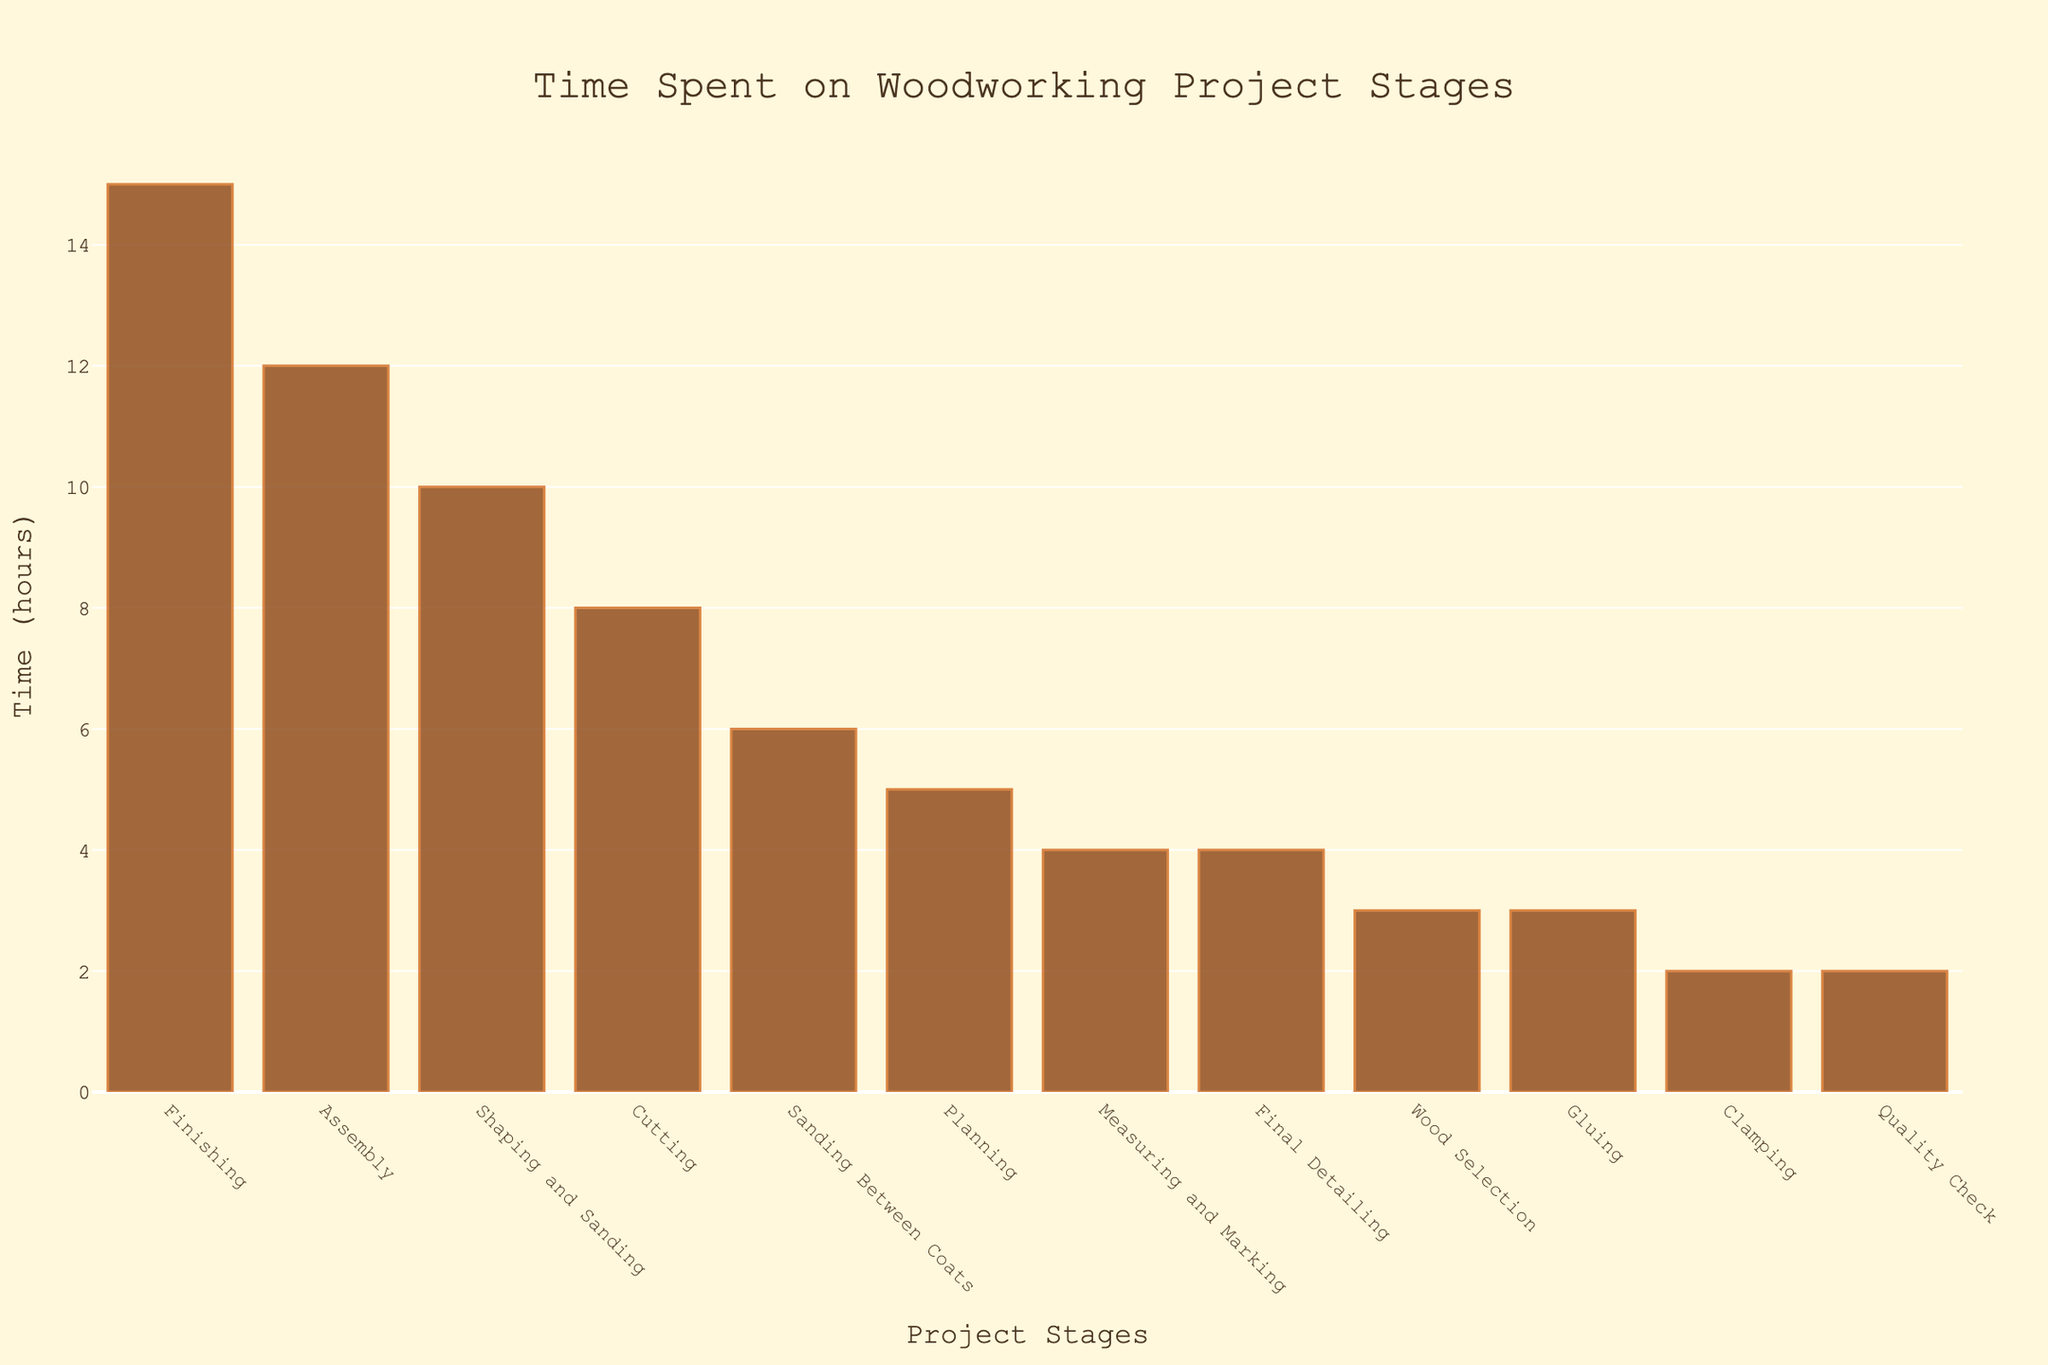Which stage takes the most time to complete? By looking at the bar chart, identify the stage with the tallest bar which represents the longest time spent.
Answer: Finishing Which stage takes the least time to complete? By looking at the bar chart, identify the stage with the shortest bar which represents the shortest time spent.
Answer: Clamping How much time is spent in the Assembly stage compared to the Planning stage? Look at the heights of the bars for the Assembly and Planning stages. The Assembly stage is 12 hours, and the Planning stage is 5 hours. Subtract the Planning time from the Assembly time. 12 - 5 = 7
Answer: 7 hours more What is the total time spent on Planning, Cutting, and Assembly stages combined? Add the times for Planning (5 hours), Cutting (8 hours), and Assembly (12 hours). 5 + 8 + 12 = 25
Answer: 25 hours Is the time spent on Shaping and Sanding greater than the time spent on Measuring and Marking? Compare the bar heights of Shaping and Sanding (10 hours) and Measuring and Marking (4 hours). Since 10 > 4, the answer is yes.
Answer: Yes Which stages take exactly 2 hours to complete? Search the bar chart for stages where the bar height is equal to 2 hours. These stages are Clamping and Quality Check.
Answer: Clamping, Quality Check What is the combined time for Gluing and Sanding Between Coats stages? Add the times for Gluing (3 hours) and Sanding Between Coats (6 hours). 3 + 6 = 9
Answer: 9 hours Which stages take more time than Cutting but less time than Assembly? Compare the time spent on stages with Cutting (8 hours) and Assembly (12 hours). The stages that satisfy this are Shaping and Sanding (10 hours) and Sanding Between Coats (6 hours).
Answer: Shaping and Sanding, Sanding Between Coats What is the average time spent on Measuring and Marking, Final Detailing, and Quality Check stages? Add the times for Measuring and Marking (4 hours), Final Detailing (4 hours), and Quality Check (2 hours) and then divide by the number of stages. (4 + 4 + 2) / 3 = 10 / 3 ≈ 3.33
Answer: 3.33 hours What is the visual difference between the longest and the shortest bars on the chart? Identify the longest bar (Finishing at 15 hours) and the shortest bar (Clamping and Quality Check at 2 hours each), then subtract the shortest time from the longest time. 15 - 2 = 13
Answer: 13 hours 